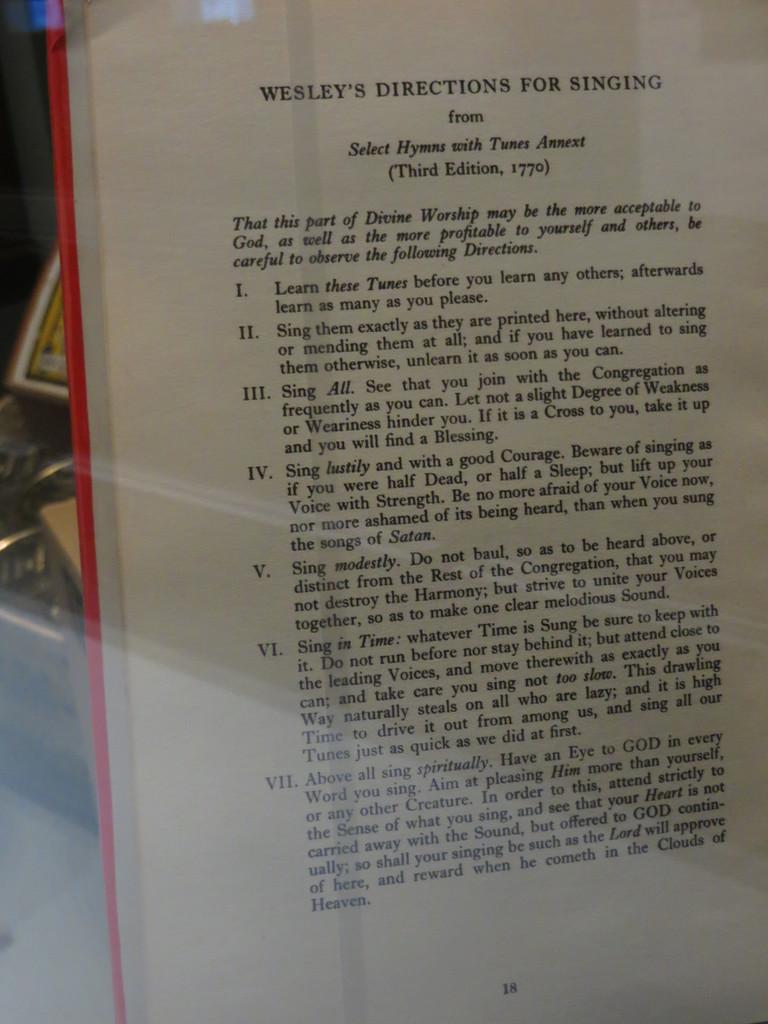Which edition is this?
Offer a terse response. Third. 